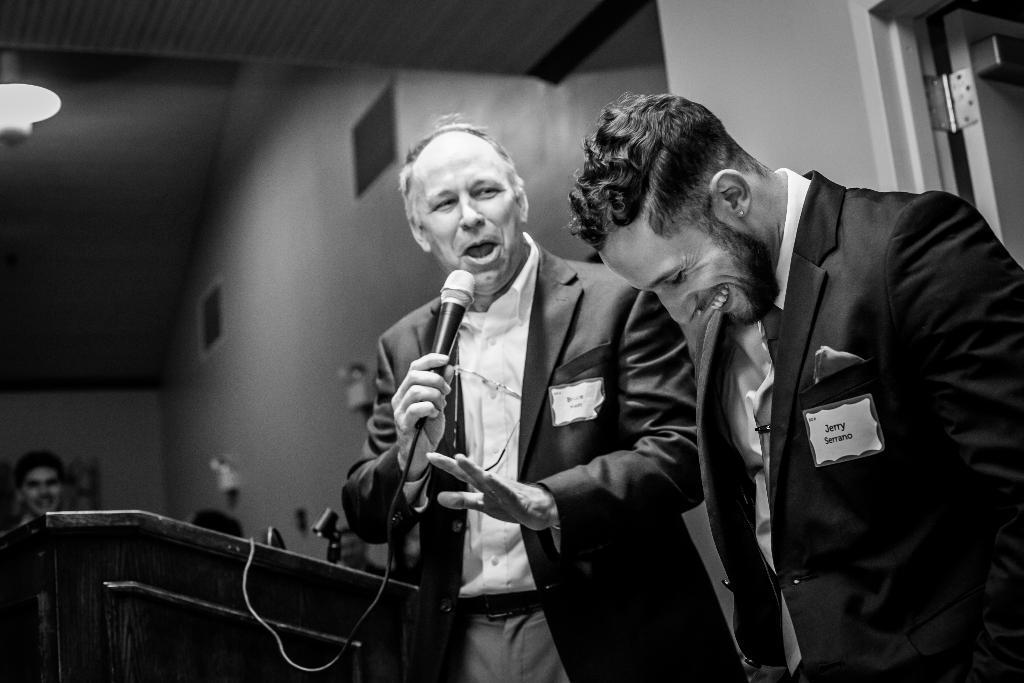Could you give a brief overview of what you see in this image? There are 2 people standing here and smiling. He is holding microphone in his hand. This is a podium. In the background we can see a light,wall and few persons. 